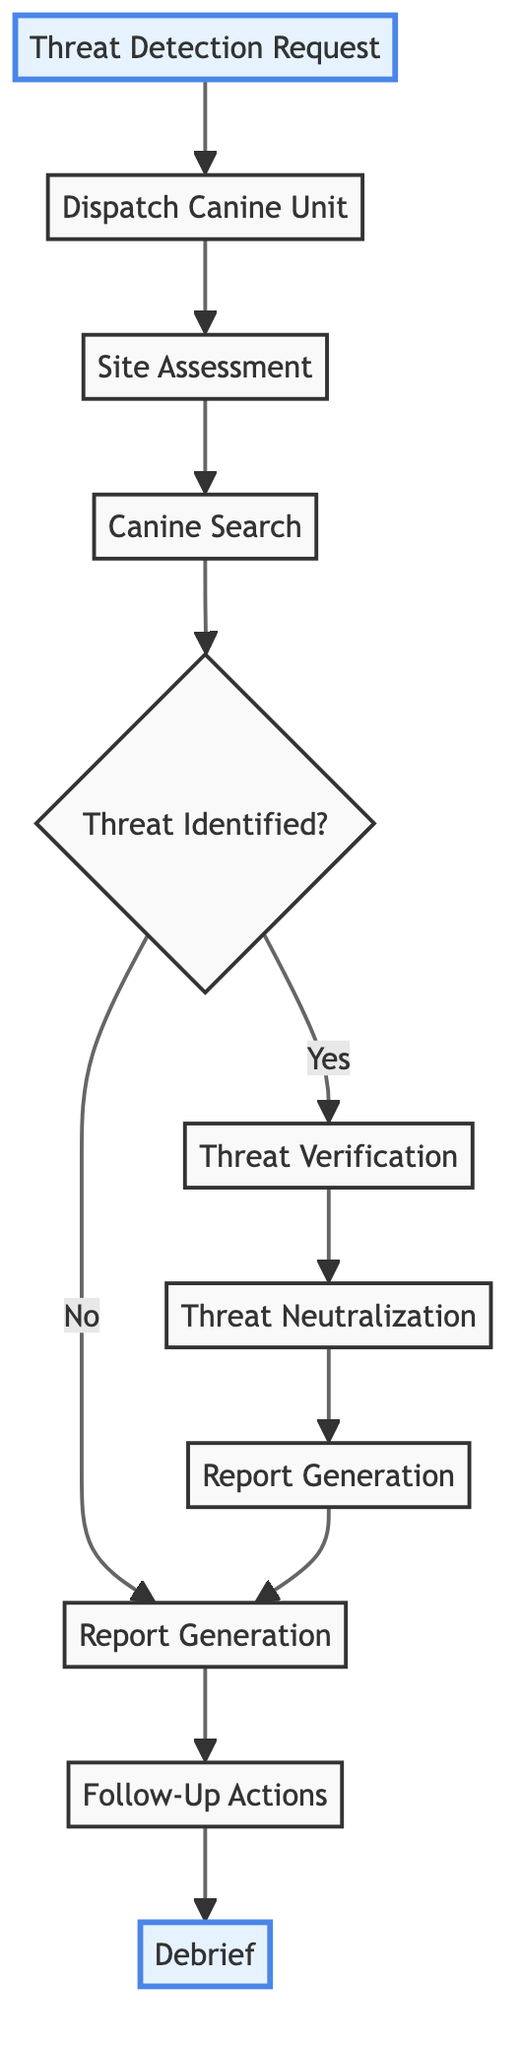What is the starting point of the workflow? The workflow begins at the "Threat Detection Request" node, which is the initial request made by the intelligence agency.
Answer: Threat Detection Request How many nodes are in the diagram? By counting each of the distinct elements listed in the diagram, we find there are a total of ten nodes.
Answer: 10 What action follows the "Site Assessment"? After the "Site Assessment" is conducted, the next action in the workflow is "Canine Search."
Answer: Canine Search Is "Threat Identification" a decision point? "Threat Identification" is represented as a decision point in the diagram, indicated by the diamond shape that asks if a threat has been identified.
Answer: Yes What happens if no threat is identified? If no threat is identified, the flow continues to "Report Generation" instead of "Threat Verification," indicating a different pathway in the workflow.
Answer: Report Generation What links are involved after "Threat Verification"? After "Threat Verification," the next action that follows is "Threat Neutralization," indicating a direct sequence from verifying to neutralizing the identified threat.
Answer: Threat Neutralization Which two steps follow the identification of a threat? Upon identifying the threat, "Threat Verification" and then "Threat Neutralization" are the subsequent steps that follow.
Answer: Threat Verification, Threat Neutralization What is the last step in the workflow after "Follow-Up Actions"? The final step that concludes the workflow after "Follow-Up Actions" is "Debrief," indicating the last point of the operational process.
Answer: Debrief How does the workflow end? The workflow ends after the "Debrief," which indicates the formal evaluation of the operation and canine performance, and is the final node in the flow.
Answer: Debrief 